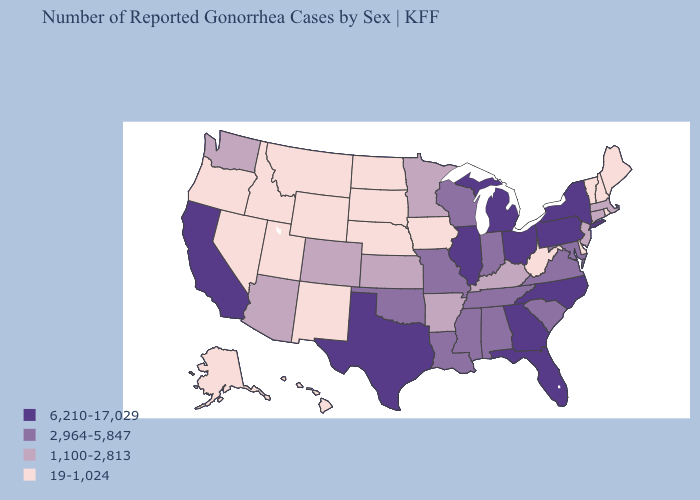Does Pennsylvania have the highest value in the Northeast?
Keep it brief. Yes. Does Kentucky have a lower value than Tennessee?
Quick response, please. Yes. Name the states that have a value in the range 19-1,024?
Concise answer only. Alaska, Delaware, Hawaii, Idaho, Iowa, Maine, Montana, Nebraska, Nevada, New Hampshire, New Mexico, North Dakota, Oregon, Rhode Island, South Dakota, Utah, Vermont, West Virginia, Wyoming. What is the value of Missouri?
Short answer required. 2,964-5,847. What is the lowest value in the USA?
Give a very brief answer. 19-1,024. What is the value of Wisconsin?
Concise answer only. 2,964-5,847. Among the states that border Colorado , which have the lowest value?
Short answer required. Nebraska, New Mexico, Utah, Wyoming. What is the lowest value in states that border Missouri?
Keep it brief. 19-1,024. What is the highest value in the USA?
Give a very brief answer. 6,210-17,029. Which states have the lowest value in the USA?
Write a very short answer. Alaska, Delaware, Hawaii, Idaho, Iowa, Maine, Montana, Nebraska, Nevada, New Hampshire, New Mexico, North Dakota, Oregon, Rhode Island, South Dakota, Utah, Vermont, West Virginia, Wyoming. Name the states that have a value in the range 6,210-17,029?
Keep it brief. California, Florida, Georgia, Illinois, Michigan, New York, North Carolina, Ohio, Pennsylvania, Texas. Name the states that have a value in the range 6,210-17,029?
Answer briefly. California, Florida, Georgia, Illinois, Michigan, New York, North Carolina, Ohio, Pennsylvania, Texas. Does New Mexico have a lower value than West Virginia?
Write a very short answer. No. Name the states that have a value in the range 6,210-17,029?
Be succinct. California, Florida, Georgia, Illinois, Michigan, New York, North Carolina, Ohio, Pennsylvania, Texas. Does South Carolina have the highest value in the South?
Quick response, please. No. 